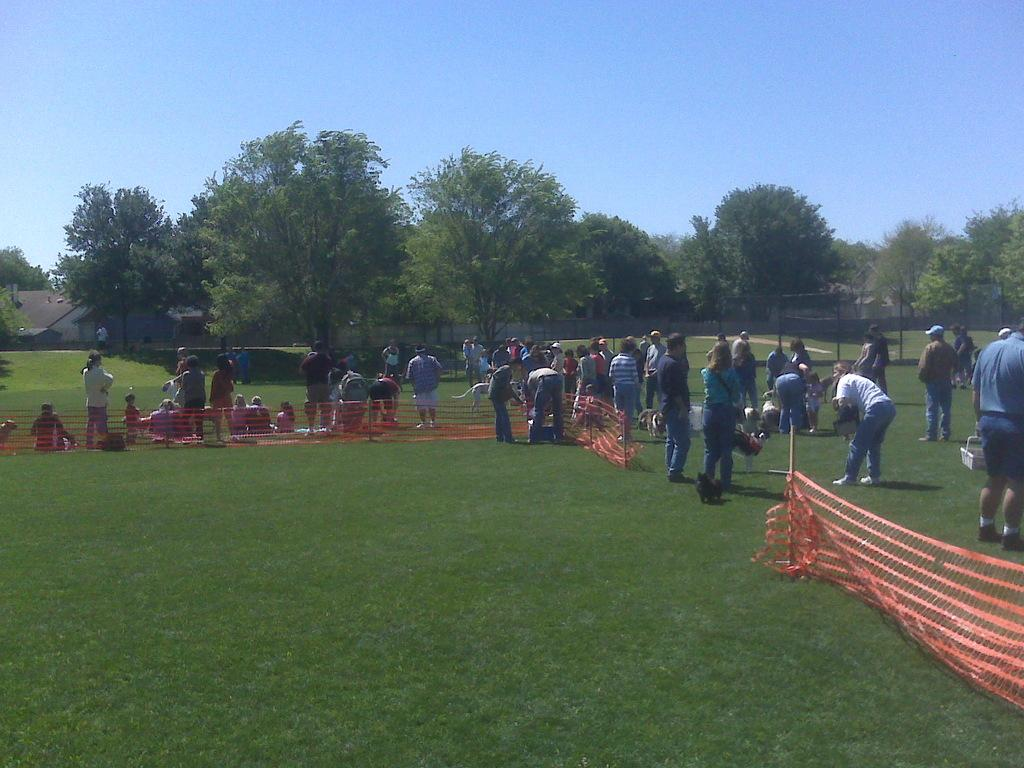How many people are in the image? There are many persons standing on the grass in the image. What can be seen in the background of the image? There is a net, trees, a building, and the sky visible in the background of the image. What size are the shoes worn by the persons in the image? There is no information about the size of the shoes worn by the persons in the image. Additionally, we cannot see the shoes they are wearing in the image. 